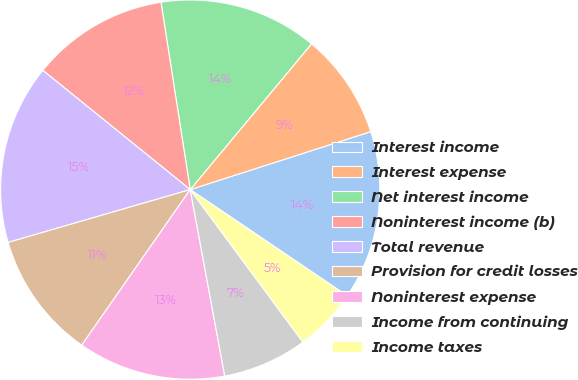Convert chart. <chart><loc_0><loc_0><loc_500><loc_500><pie_chart><fcel>Interest income<fcel>Interest expense<fcel>Net interest income<fcel>Noninterest income (b)<fcel>Total revenue<fcel>Provision for credit losses<fcel>Noninterest expense<fcel>Income from continuing<fcel>Income taxes<nl><fcel>14.41%<fcel>9.01%<fcel>13.51%<fcel>11.71%<fcel>15.32%<fcel>10.81%<fcel>12.61%<fcel>7.21%<fcel>5.41%<nl></chart> 